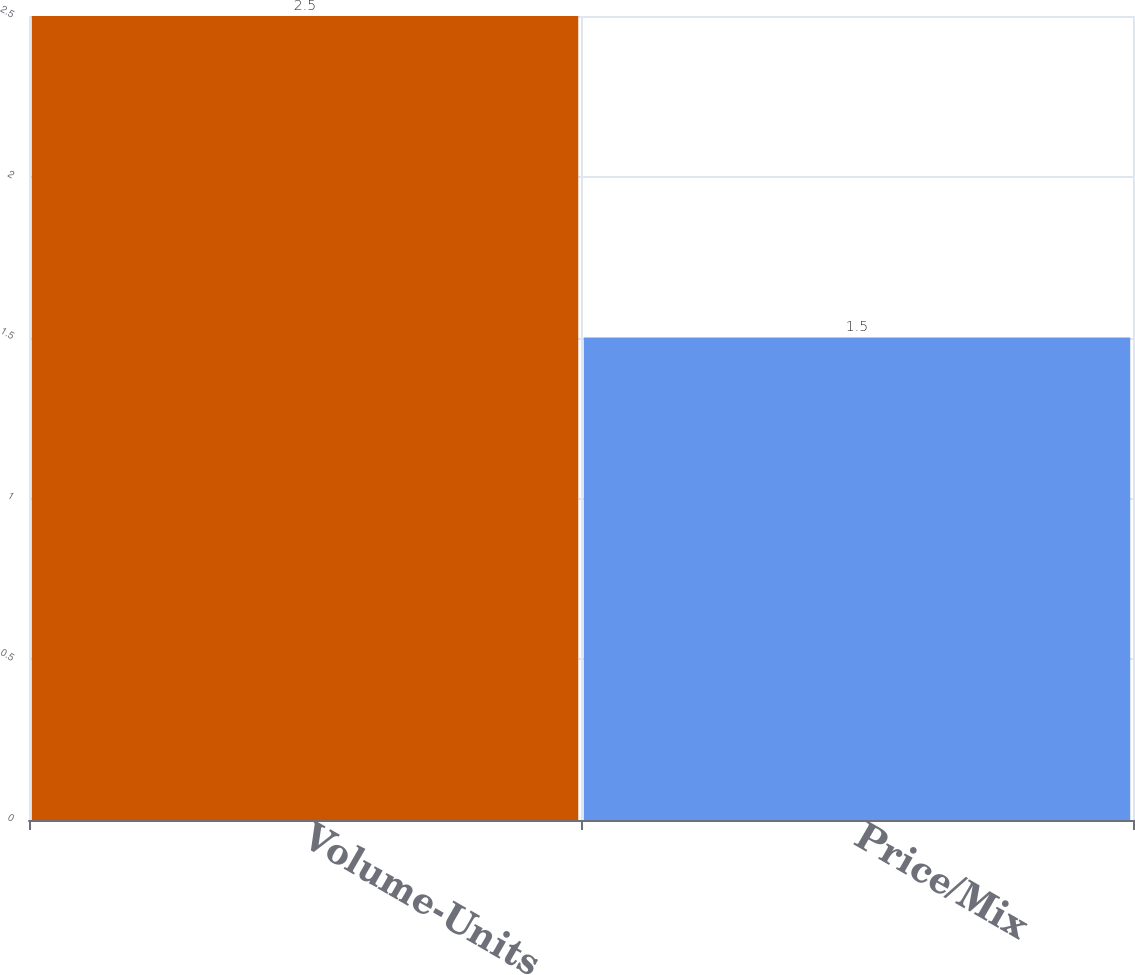Convert chart. <chart><loc_0><loc_0><loc_500><loc_500><bar_chart><fcel>Volume-Units<fcel>Price/Mix<nl><fcel>2.5<fcel>1.5<nl></chart> 